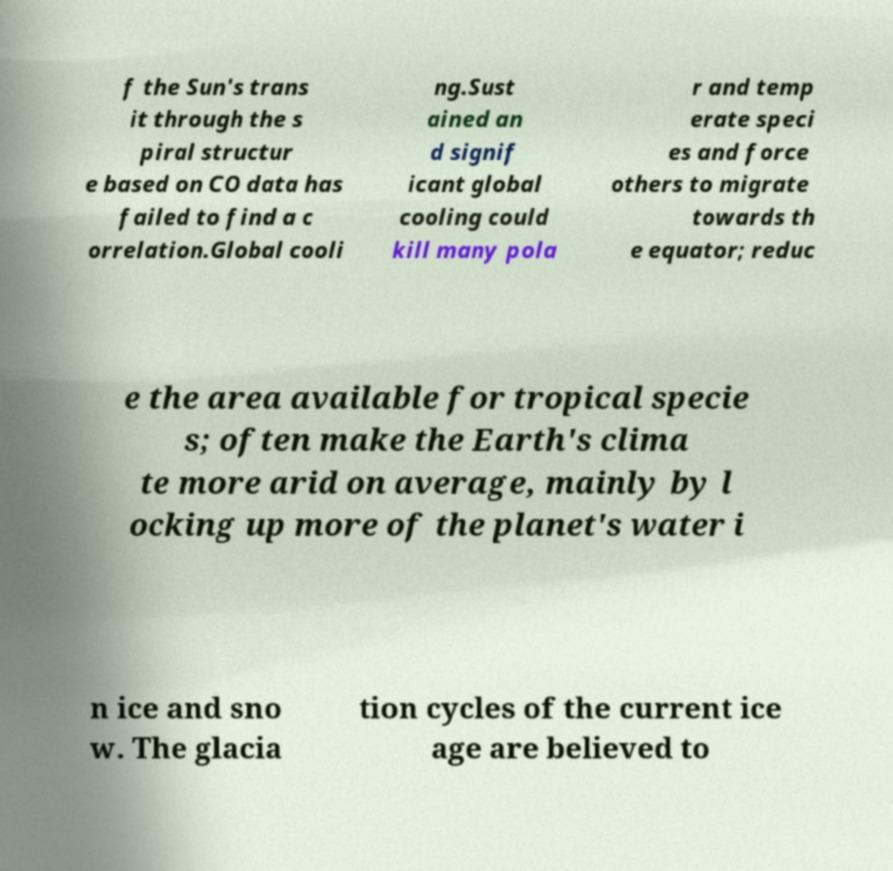Can you accurately transcribe the text from the provided image for me? f the Sun's trans it through the s piral structur e based on CO data has failed to find a c orrelation.Global cooli ng.Sust ained an d signif icant global cooling could kill many pola r and temp erate speci es and force others to migrate towards th e equator; reduc e the area available for tropical specie s; often make the Earth's clima te more arid on average, mainly by l ocking up more of the planet's water i n ice and sno w. The glacia tion cycles of the current ice age are believed to 